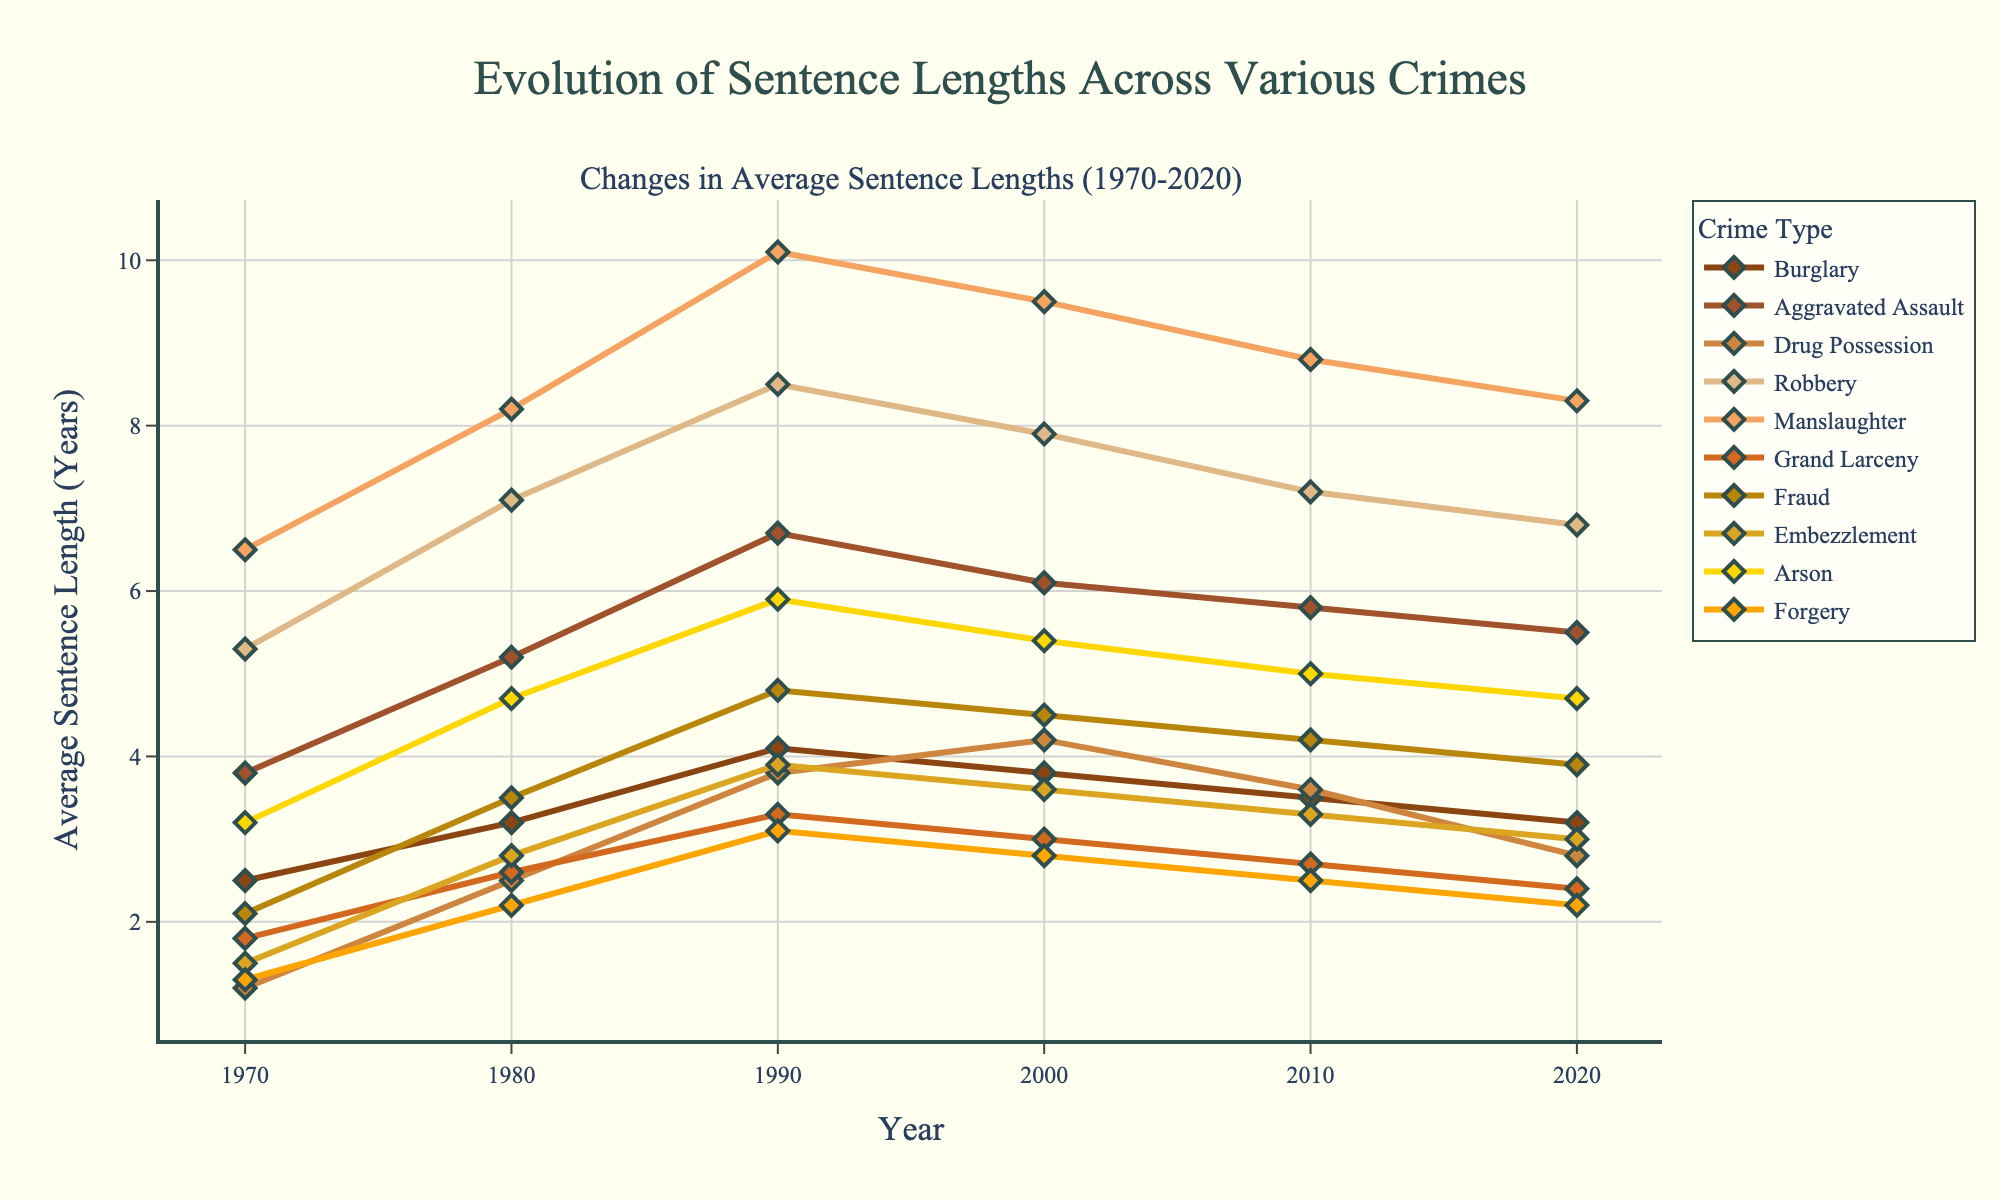Which crime type had the longest average sentence length in 2020? To answer this, we look for the highest point on the 2020 axis across all lines. The crime type with the highest value in 2020 is Manslaughter with an average sentence length of 8.3 years.
Answer: Manslaughter What's the sum of average sentence lengths for Drug Possession and Robbery in 1990? First, we find the values for Drug Possession and Robbery in 1990, which are 3.8 and 8.5 years respectively. Summing these values gives 3.8 + 8.5 = 12.3.
Answer: 12.3 How many crimes had a decreasing trend in average sentence length from 2010 to 2020? To determine this, we compare the 2010 and 2020 values for each crime type and count those for which the 2020 value is lower than the 2010 value. Burglary, Drug Possession, Robbery, Manslaughter, Grand Larceny, Fraud, Embezzlement, Arson, and Forgery all show a decrease, totaling 9 crime types.
Answer: 9 Which crime type showed the highest increase in average sentence length between 1970 and 1990? Compute the difference in average sentence lengths between 1970 and 1990 for each crime. The highest increase comes from the crime with the largest difference value. For instance, Manslaughter increased from 6.5 in 1970 to 10.1 in 1990, an increase of 3.6 years, which is the highest among all crimes.
Answer: Manslaughter Between 2000 and 2020, which crime type had the most consistent (least varying) average sentence lengths? To find this, we check the values for each crime type from 2000 to 2020 and look for the one with the smallest range (difference between the maximum and minimum values). Checking for consistency, Burglary ranges from 3.8 to 3.2, showing the smallest difference of 0.6 years.
Answer: Burglary What is the average sentence length for Embezzlement in the decade of the 1980s? First, identify the values for Embezzlement in 1980 and 1990, which are 2.8 and 3.9 years respectively. Since we’re averaging over the decade, compute the average of these two values: (2.8 + 3.9) / 2 = 3.35 years.
Answer: 3.35 Which two crime types have almost parallel trends from 1980 to 2020? By visually comparing the slopes of the lines for each crime type between 1980 and 2020, we identify Grand Larceny and Forgery as having similar slopes and trends, implying they have almost parallel trends over these years.
Answer: Grand Larceny and Forgery What was the smallest sentence length recorded in 1970 and which crime type did it correspond to? Check the 1970 values across all crime types and identify the smallest value. The smallest sentence length recorded in 1970 is 1.2 years, corresponding to Drug Possession.
Answer: Drug Possession What is the average increase in sentence lengths from 1970 to 1980 across all crime types? First, compute the individual increases for each crime type from 1970 to 1980, then find the average. For example, increases are: Burglary (3.2-2.5=0.7), Aggravated Assault (5.2-3.8=1.4), etc. Summing these increases and dividing by the number of crime types gives the average increase: (0.7 + 1.4 + 1.3 + 1.8 + 1.7 + 0.8 + 1.4 + 1.3 + 1.5 + 0.9) / 10 = 1.24.
Answer: 1.24 